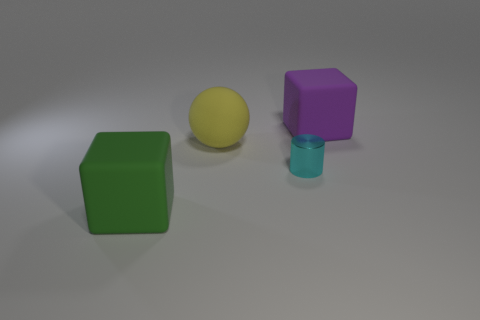Add 1 small purple metallic cylinders. How many objects exist? 5 Subtract all spheres. How many objects are left? 3 Subtract all large yellow matte objects. Subtract all yellow spheres. How many objects are left? 2 Add 1 cyan metal cylinders. How many cyan metal cylinders are left? 2 Add 1 purple rubber objects. How many purple rubber objects exist? 2 Subtract 0 cyan cubes. How many objects are left? 4 